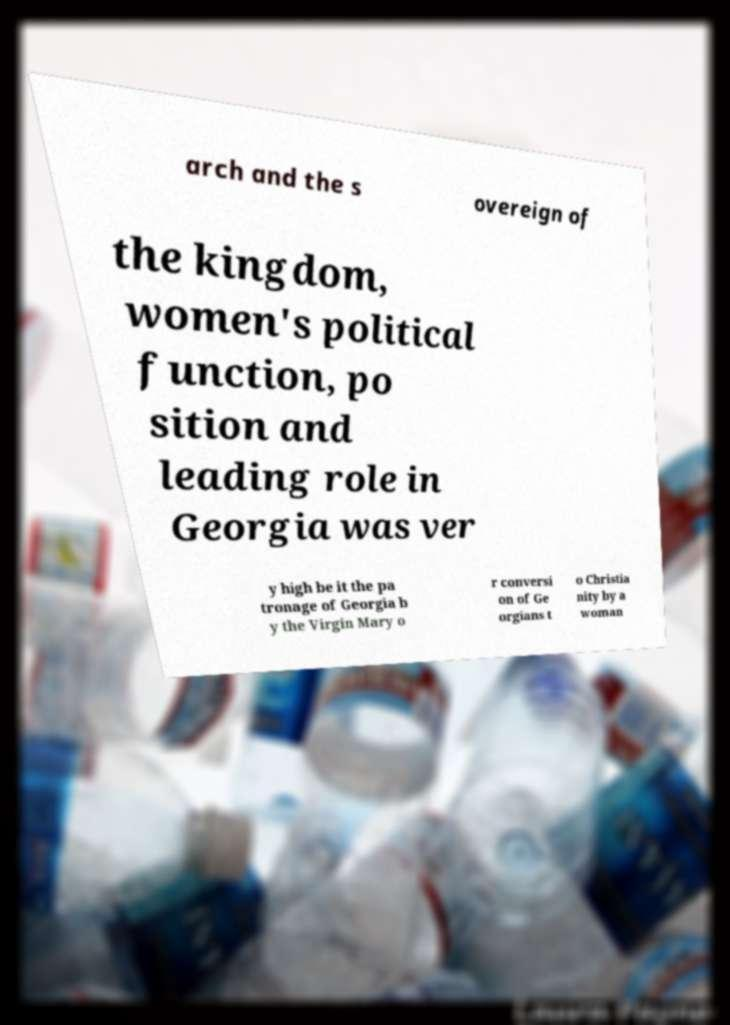What messages or text are displayed in this image? I need them in a readable, typed format. arch and the s overeign of the kingdom, women's political function, po sition and leading role in Georgia was ver y high be it the pa tronage of Georgia b y the Virgin Mary o r conversi on of Ge orgians t o Christia nity by a woman 